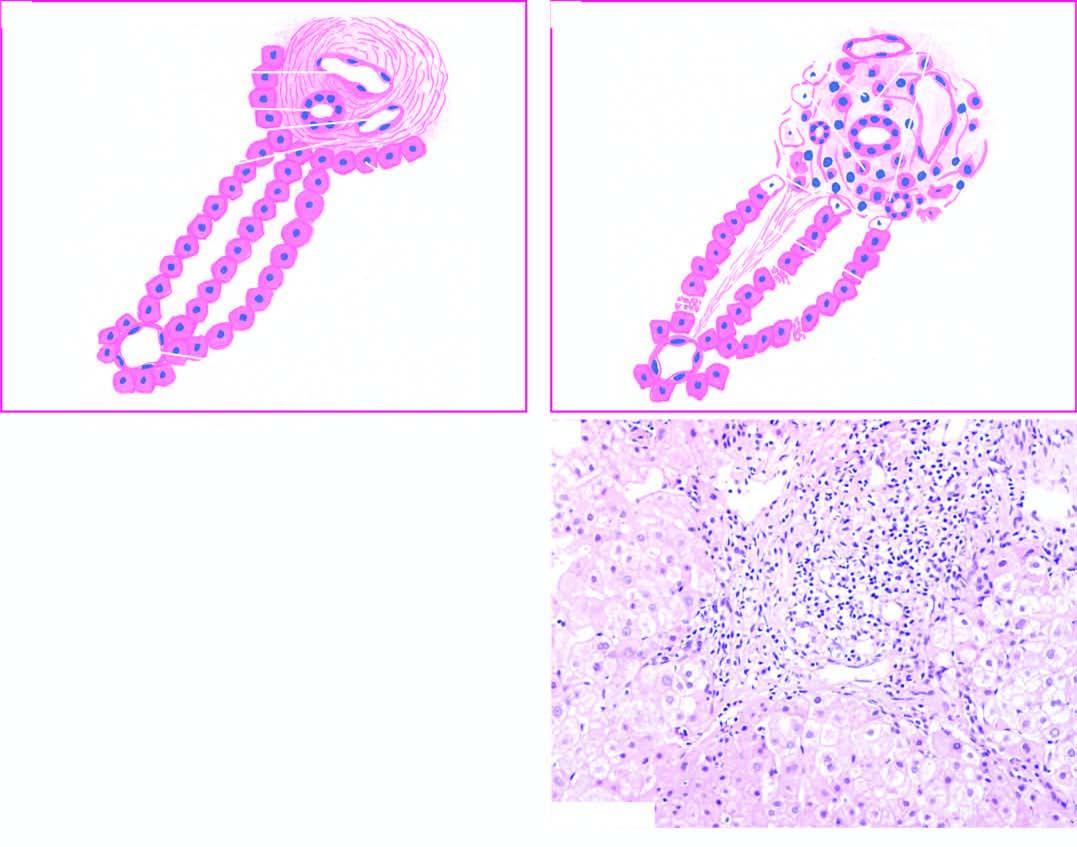how is diagrammatic representation of pathologic changes in chronic hepatitis contrasted?
Answer the question using a single word or phrase. With normal morphology 